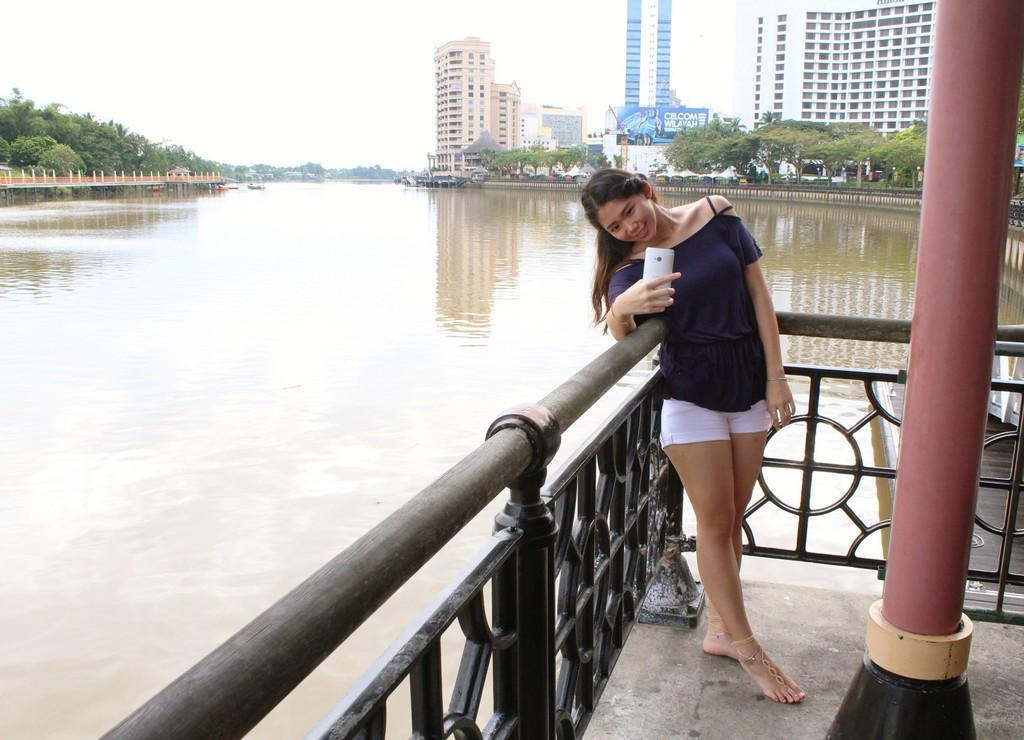What is one of the natural elements present in the image? There is water in the image. What type of vegetation can be seen in the image? There are trees in the image. What type of man-made structures are visible in the image? There are buildings in the image. What part of the natural environment is visible in the image? The sky is visible in the image. Can you describe the woman in the image? The woman is wearing a black dress and holding a mobile phone. How many mittens are being worn by the woman in the image? There are no mittens present in the image; the woman is wearing a black dress and holding a mobile phone. 